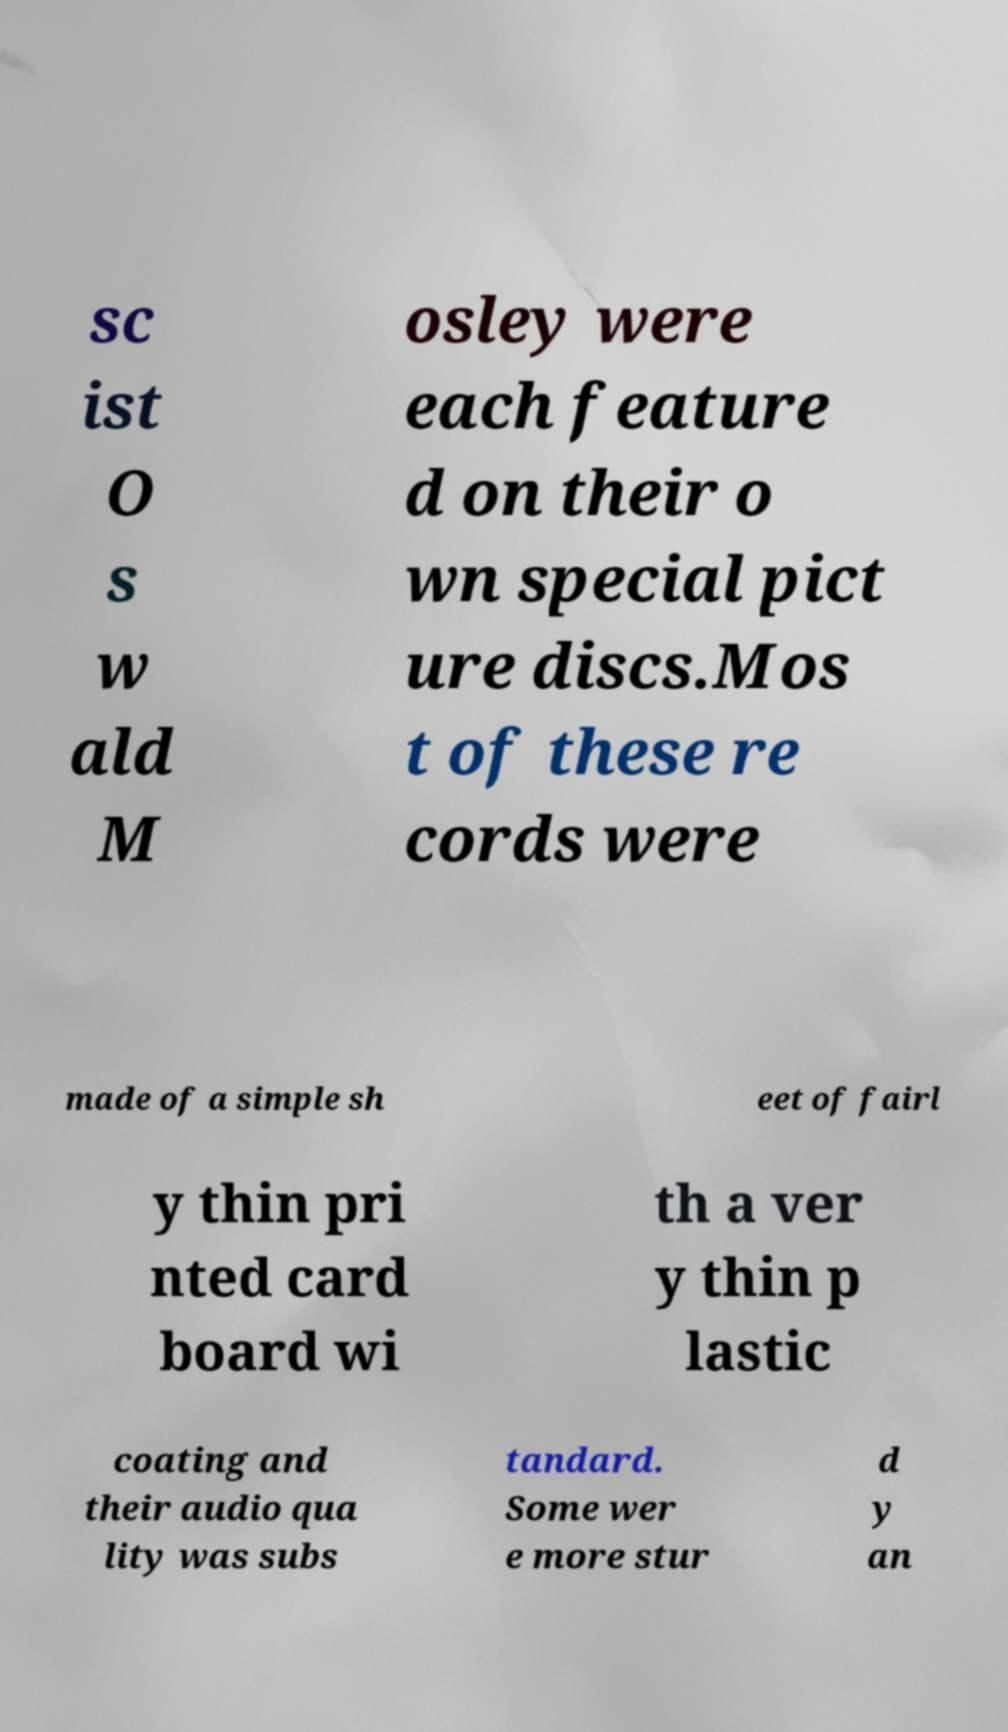Could you assist in decoding the text presented in this image and type it out clearly? sc ist O s w ald M osley were each feature d on their o wn special pict ure discs.Mos t of these re cords were made of a simple sh eet of fairl y thin pri nted card board wi th a ver y thin p lastic coating and their audio qua lity was subs tandard. Some wer e more stur d y an 